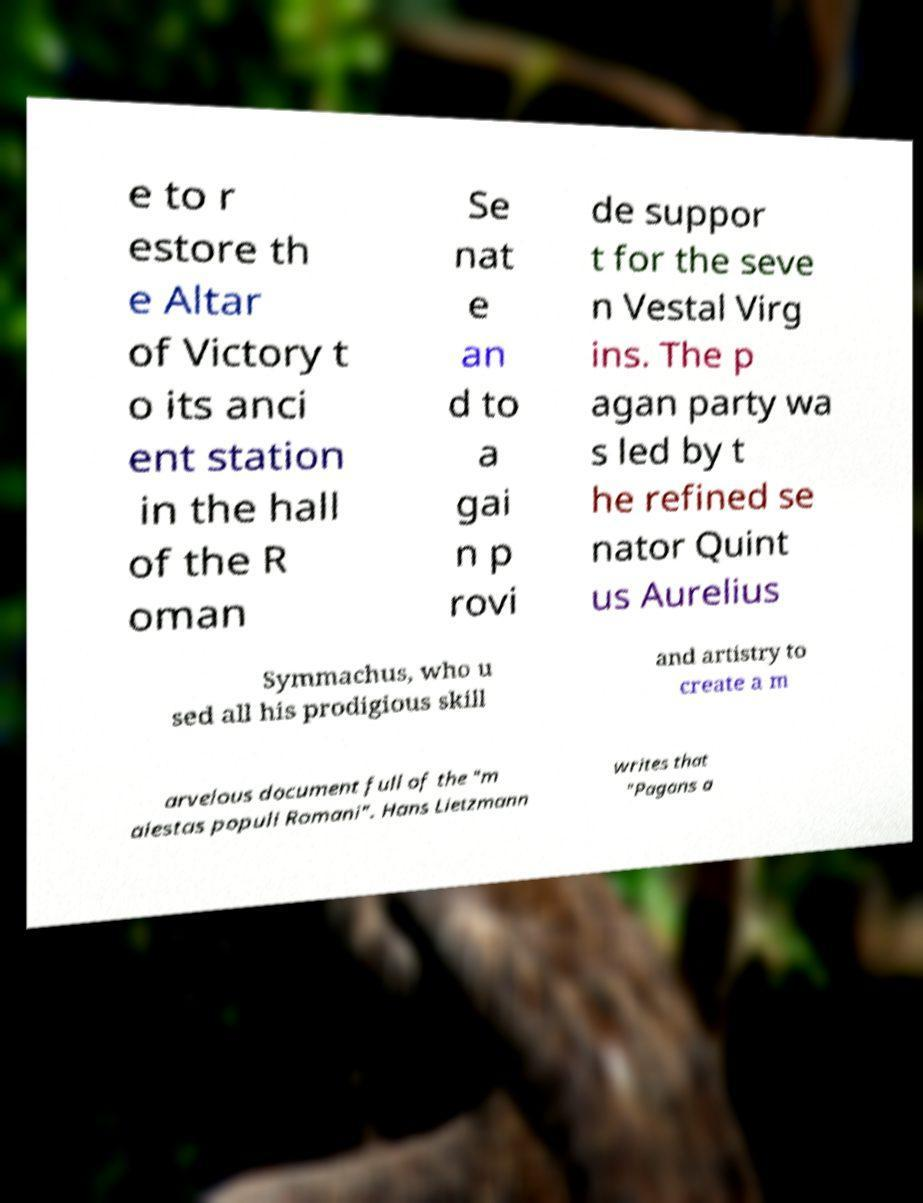There's text embedded in this image that I need extracted. Can you transcribe it verbatim? e to r estore th e Altar of Victory t o its anci ent station in the hall of the R oman Se nat e an d to a gai n p rovi de suppor t for the seve n Vestal Virg ins. The p agan party wa s led by t he refined se nator Quint us Aurelius Symmachus, who u sed all his prodigious skill and artistry to create a m arvelous document full of the "m aiestas populi Romani". Hans Lietzmann writes that "Pagans a 